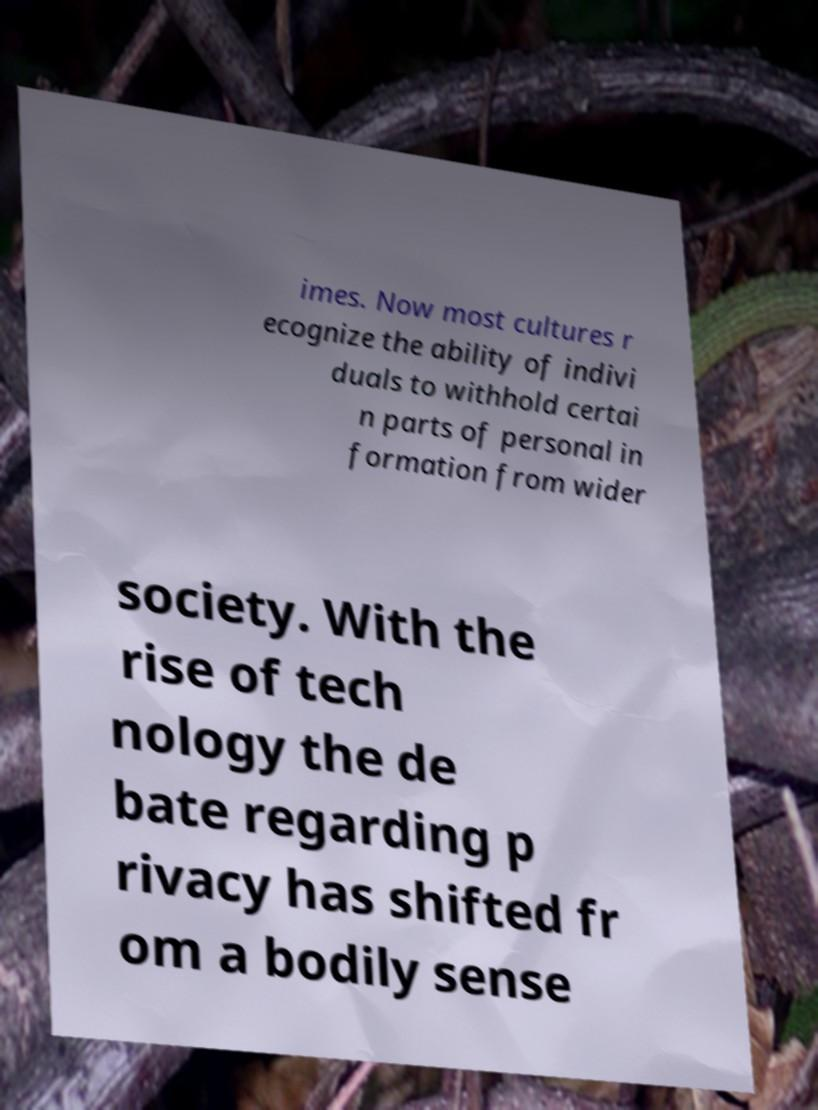Could you extract and type out the text from this image? imes. Now most cultures r ecognize the ability of indivi duals to withhold certai n parts of personal in formation from wider society. With the rise of tech nology the de bate regarding p rivacy has shifted fr om a bodily sense 